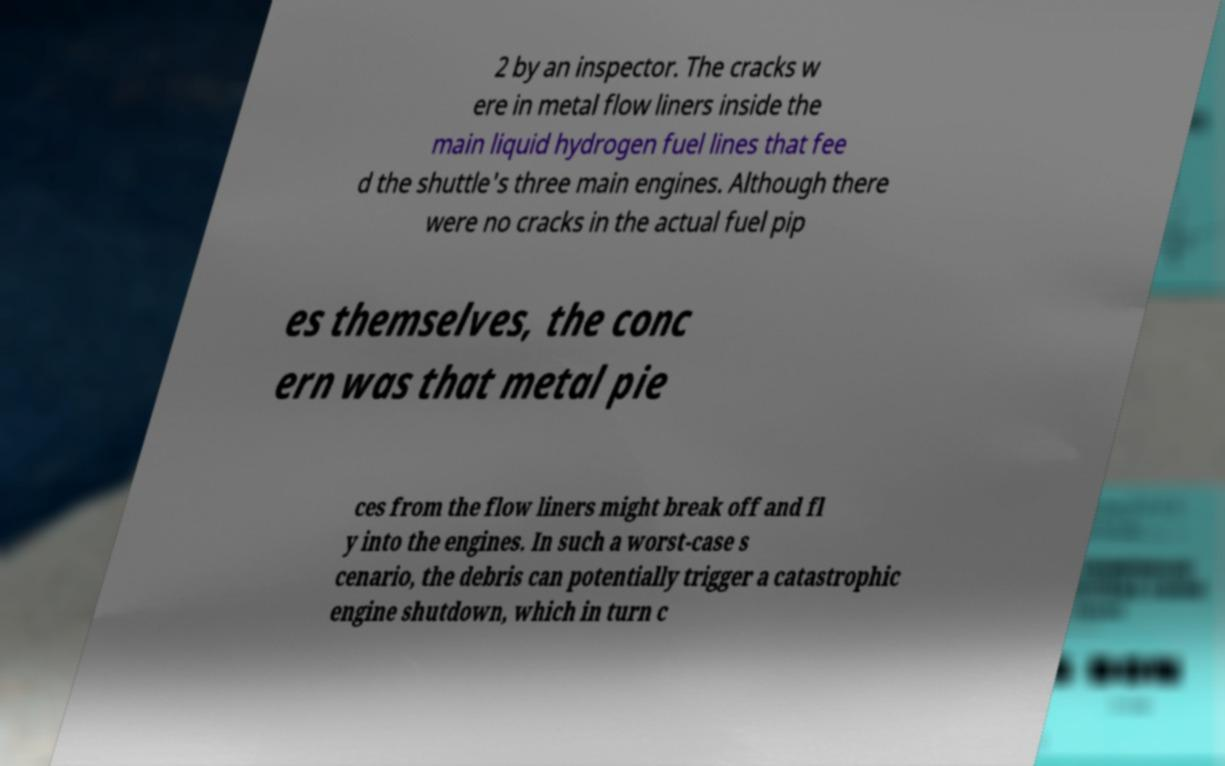Please read and relay the text visible in this image. What does it say? 2 by an inspector. The cracks w ere in metal flow liners inside the main liquid hydrogen fuel lines that fee d the shuttle's three main engines. Although there were no cracks in the actual fuel pip es themselves, the conc ern was that metal pie ces from the flow liners might break off and fl y into the engines. In such a worst-case s cenario, the debris can potentially trigger a catastrophic engine shutdown, which in turn c 